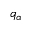<formula> <loc_0><loc_0><loc_500><loc_500>q _ { \alpha }</formula> 